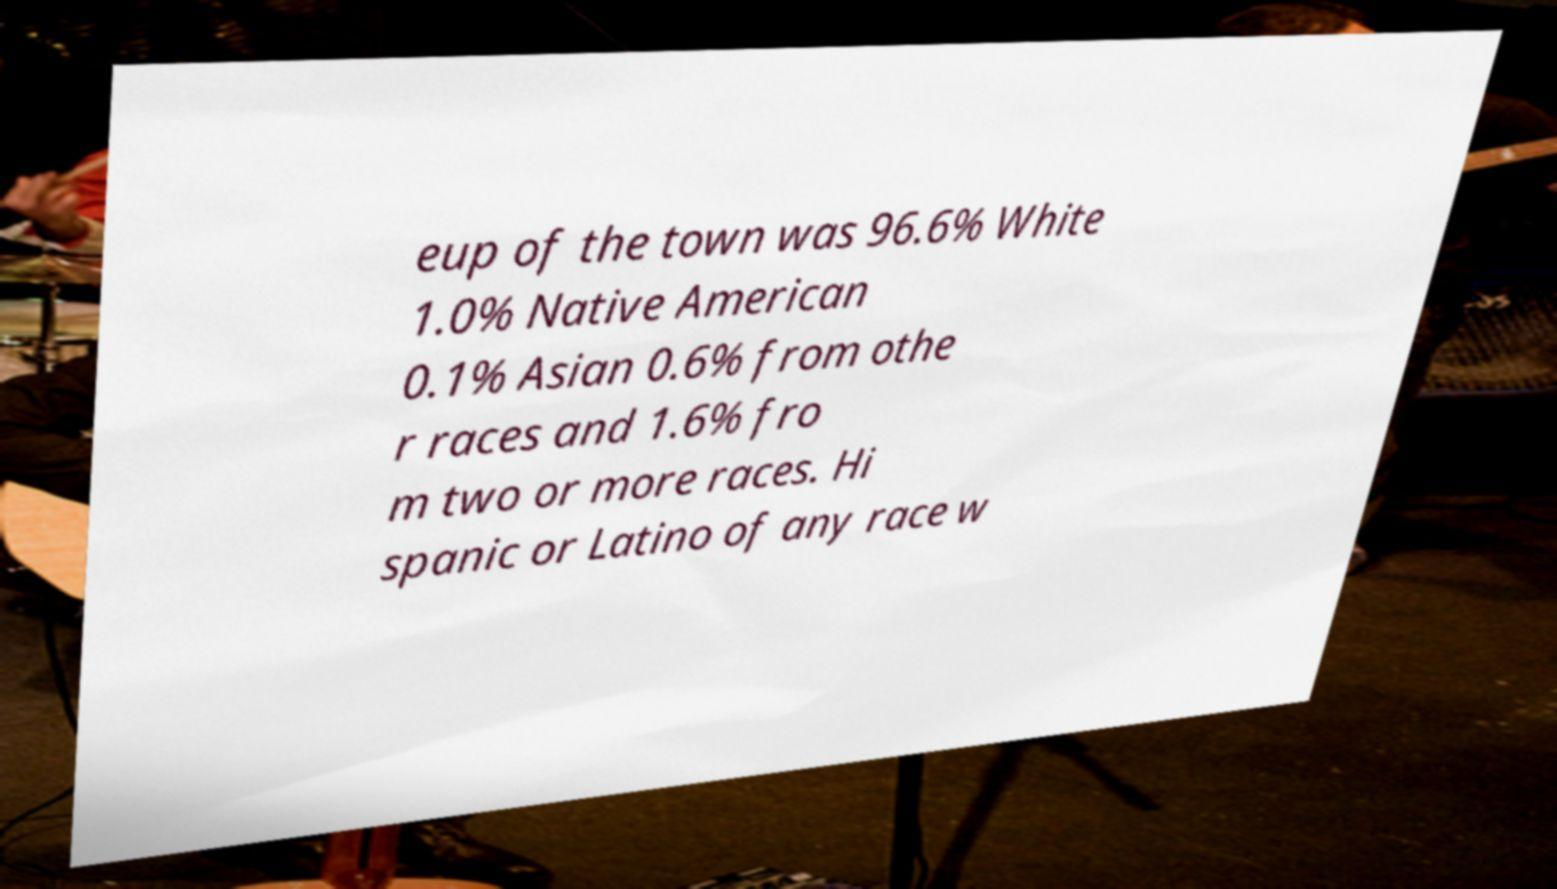I need the written content from this picture converted into text. Can you do that? eup of the town was 96.6% White 1.0% Native American 0.1% Asian 0.6% from othe r races and 1.6% fro m two or more races. Hi spanic or Latino of any race w 